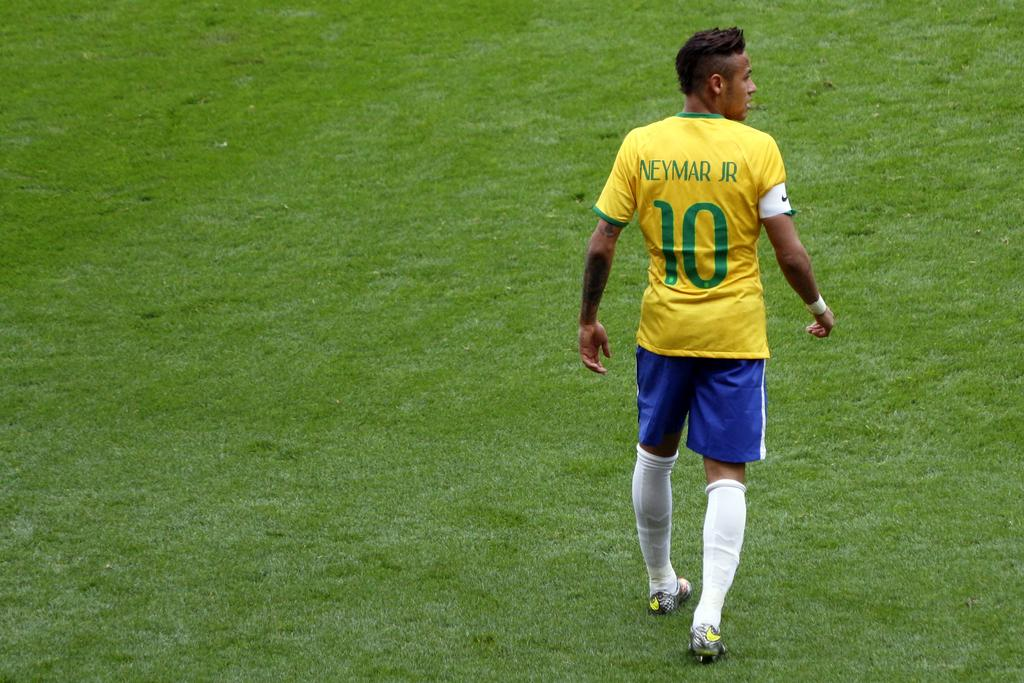Who is in the image? There is a person in the image. What is the person wearing? The person is wearing a t-shirt. What is the t-shirt's design? The t-shirt has the number ten and "Neymar Jr" written on it. What is the person doing in the image? The person is walking on the ground. What type of surface is the person walking on? Grass is visible everywhere in the image. What type of paper is visible in the image? There is no paper present in the image. Is the queen in the image? There is no mention of a queen or any royal figure in the image. 